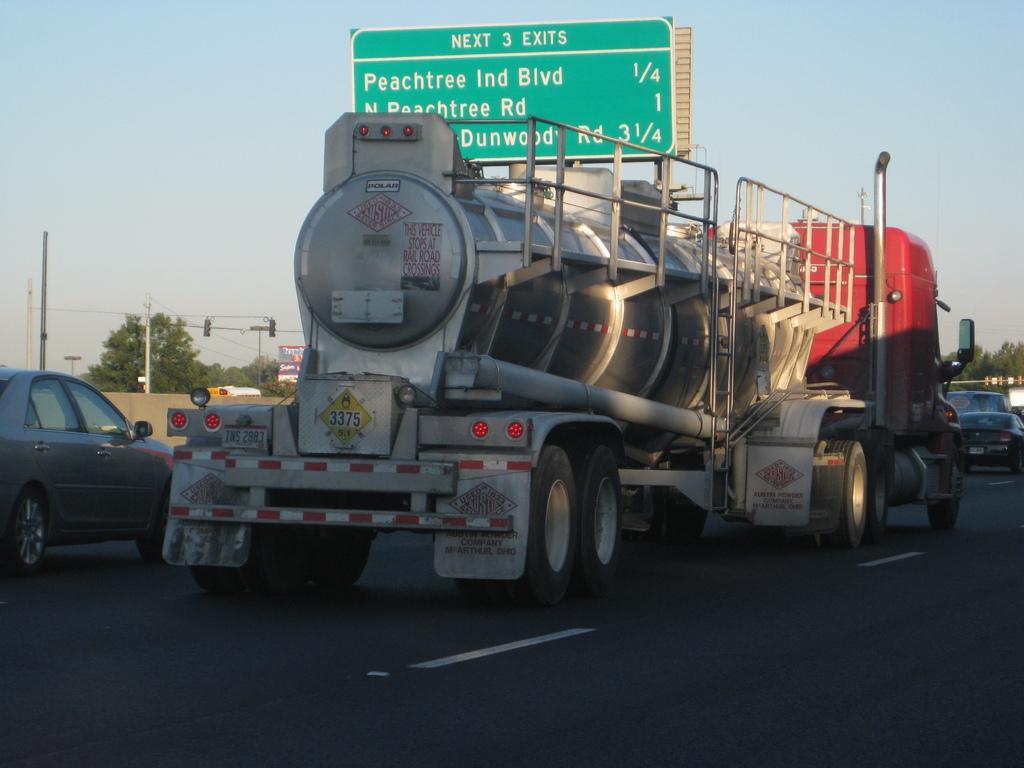Describe this image in one or two sentences. In this image, we can see few vehicles on the road. Background we can see wall, trees, poles, traffic signals, banner, board and sky. 